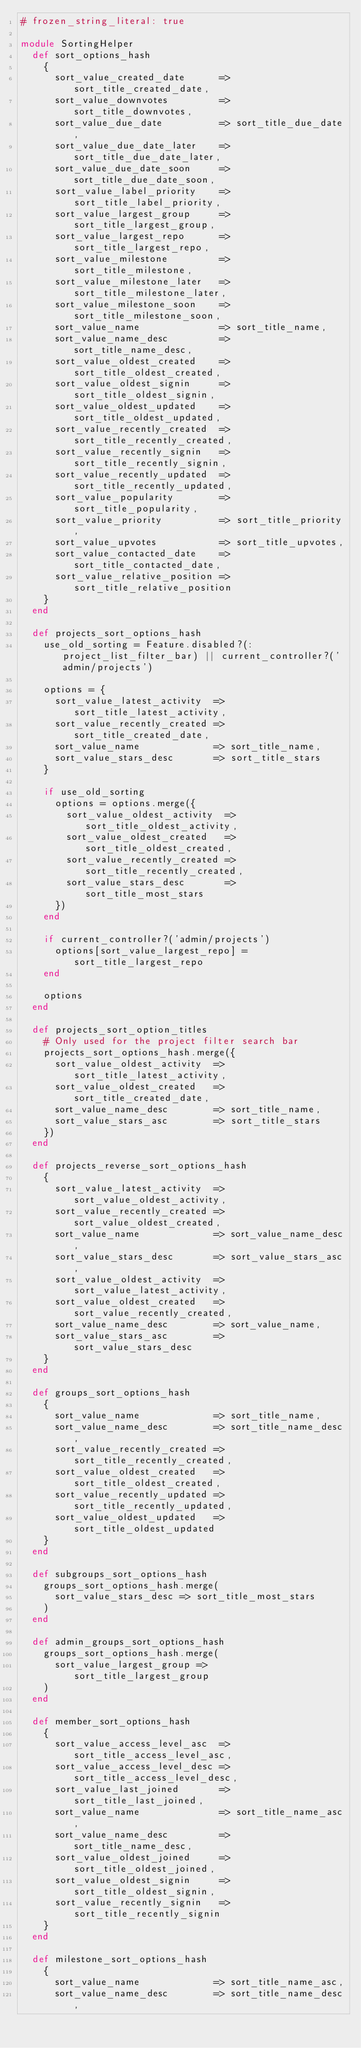Convert code to text. <code><loc_0><loc_0><loc_500><loc_500><_Ruby_># frozen_string_literal: true

module SortingHelper
  def sort_options_hash
    {
      sort_value_created_date      => sort_title_created_date,
      sort_value_downvotes         => sort_title_downvotes,
      sort_value_due_date          => sort_title_due_date,
      sort_value_due_date_later    => sort_title_due_date_later,
      sort_value_due_date_soon     => sort_title_due_date_soon,
      sort_value_label_priority    => sort_title_label_priority,
      sort_value_largest_group     => sort_title_largest_group,
      sort_value_largest_repo      => sort_title_largest_repo,
      sort_value_milestone         => sort_title_milestone,
      sort_value_milestone_later   => sort_title_milestone_later,
      sort_value_milestone_soon    => sort_title_milestone_soon,
      sort_value_name              => sort_title_name,
      sort_value_name_desc         => sort_title_name_desc,
      sort_value_oldest_created    => sort_title_oldest_created,
      sort_value_oldest_signin     => sort_title_oldest_signin,
      sort_value_oldest_updated    => sort_title_oldest_updated,
      sort_value_recently_created  => sort_title_recently_created,
      sort_value_recently_signin   => sort_title_recently_signin,
      sort_value_recently_updated  => sort_title_recently_updated,
      sort_value_popularity        => sort_title_popularity,
      sort_value_priority          => sort_title_priority,
      sort_value_upvotes           => sort_title_upvotes,
      sort_value_contacted_date    => sort_title_contacted_date,
      sort_value_relative_position => sort_title_relative_position
    }
  end

  def projects_sort_options_hash
    use_old_sorting = Feature.disabled?(:project_list_filter_bar) || current_controller?('admin/projects')

    options = {
      sort_value_latest_activity  => sort_title_latest_activity,
      sort_value_recently_created => sort_title_created_date,
      sort_value_name             => sort_title_name,
      sort_value_stars_desc       => sort_title_stars
    }

    if use_old_sorting
      options = options.merge({
        sort_value_oldest_activity  => sort_title_oldest_activity,
        sort_value_oldest_created   => sort_title_oldest_created,
        sort_value_recently_created => sort_title_recently_created,
        sort_value_stars_desc       => sort_title_most_stars
      })
    end

    if current_controller?('admin/projects')
      options[sort_value_largest_repo] = sort_title_largest_repo
    end

    options
  end

  def projects_sort_option_titles
    # Only used for the project filter search bar
    projects_sort_options_hash.merge({
      sort_value_oldest_activity  => sort_title_latest_activity,
      sort_value_oldest_created   => sort_title_created_date,
      sort_value_name_desc        => sort_title_name,
      sort_value_stars_asc        => sort_title_stars
    })
  end

  def projects_reverse_sort_options_hash
    {
      sort_value_latest_activity  => sort_value_oldest_activity,
      sort_value_recently_created => sort_value_oldest_created,
      sort_value_name             => sort_value_name_desc,
      sort_value_stars_desc       => sort_value_stars_asc,
      sort_value_oldest_activity  => sort_value_latest_activity,
      sort_value_oldest_created   => sort_value_recently_created,
      sort_value_name_desc        => sort_value_name,
      sort_value_stars_asc        => sort_value_stars_desc
    }
  end

  def groups_sort_options_hash
    {
      sort_value_name             => sort_title_name,
      sort_value_name_desc        => sort_title_name_desc,
      sort_value_recently_created => sort_title_recently_created,
      sort_value_oldest_created   => sort_title_oldest_created,
      sort_value_recently_updated => sort_title_recently_updated,
      sort_value_oldest_updated   => sort_title_oldest_updated
    }
  end

  def subgroups_sort_options_hash
    groups_sort_options_hash.merge(
      sort_value_stars_desc => sort_title_most_stars
    )
  end

  def admin_groups_sort_options_hash
    groups_sort_options_hash.merge(
      sort_value_largest_group => sort_title_largest_group
    )
  end

  def member_sort_options_hash
    {
      sort_value_access_level_asc  => sort_title_access_level_asc,
      sort_value_access_level_desc => sort_title_access_level_desc,
      sort_value_last_joined       => sort_title_last_joined,
      sort_value_name              => sort_title_name_asc,
      sort_value_name_desc         => sort_title_name_desc,
      sort_value_oldest_joined     => sort_title_oldest_joined,
      sort_value_oldest_signin     => sort_title_oldest_signin,
      sort_value_recently_signin   => sort_title_recently_signin
    }
  end

  def milestone_sort_options_hash
    {
      sort_value_name             => sort_title_name_asc,
      sort_value_name_desc        => sort_title_name_desc,</code> 